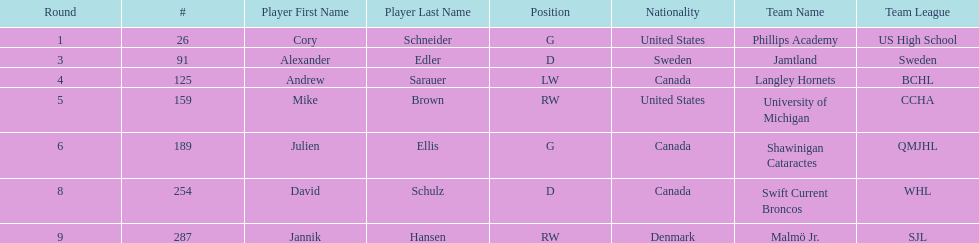What number of players have canada listed as their nationality? 3. 